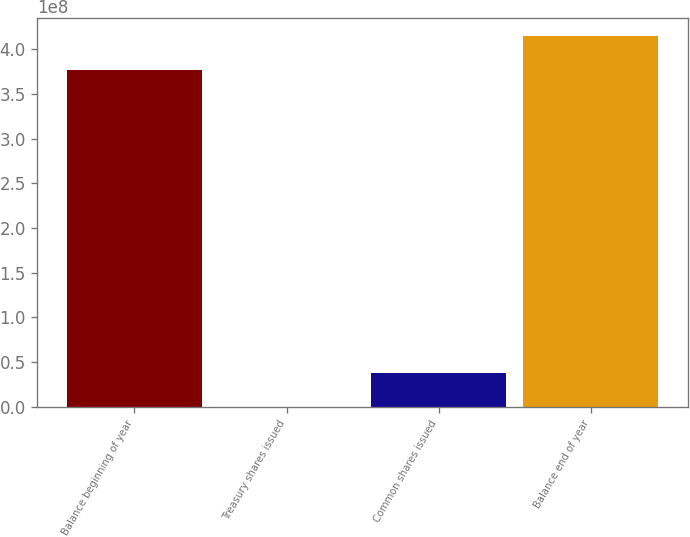Convert chart. <chart><loc_0><loc_0><loc_500><loc_500><bar_chart><fcel>Balance beginning of year<fcel>Treasury shares issued<fcel>Common shares issued<fcel>Balance end of year<nl><fcel>3.76505e+08<fcel>17525<fcel>3.78192e+07<fcel>4.14307e+08<nl></chart> 